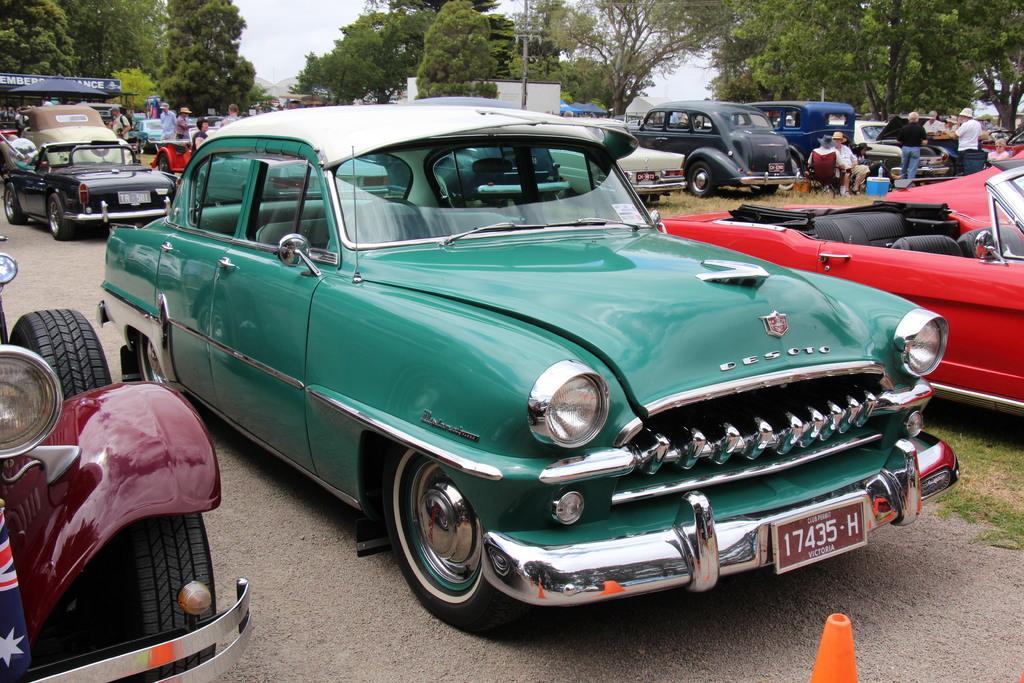Please provide a concise description of this image. In this image there are so many cars parked on the road. In the background there are trees. There are few people standing in between the cars. On the right side there are few people sitting in the chairs which are on the ground. At the bottom there is a safety cone. 